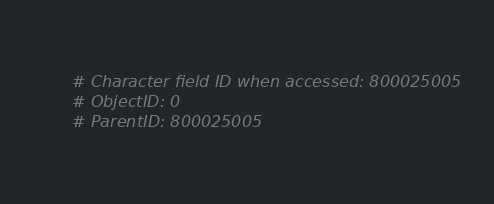Convert code to text. <code><loc_0><loc_0><loc_500><loc_500><_Python_># Character field ID when accessed: 800025005
# ObjectID: 0
# ParentID: 800025005
</code> 